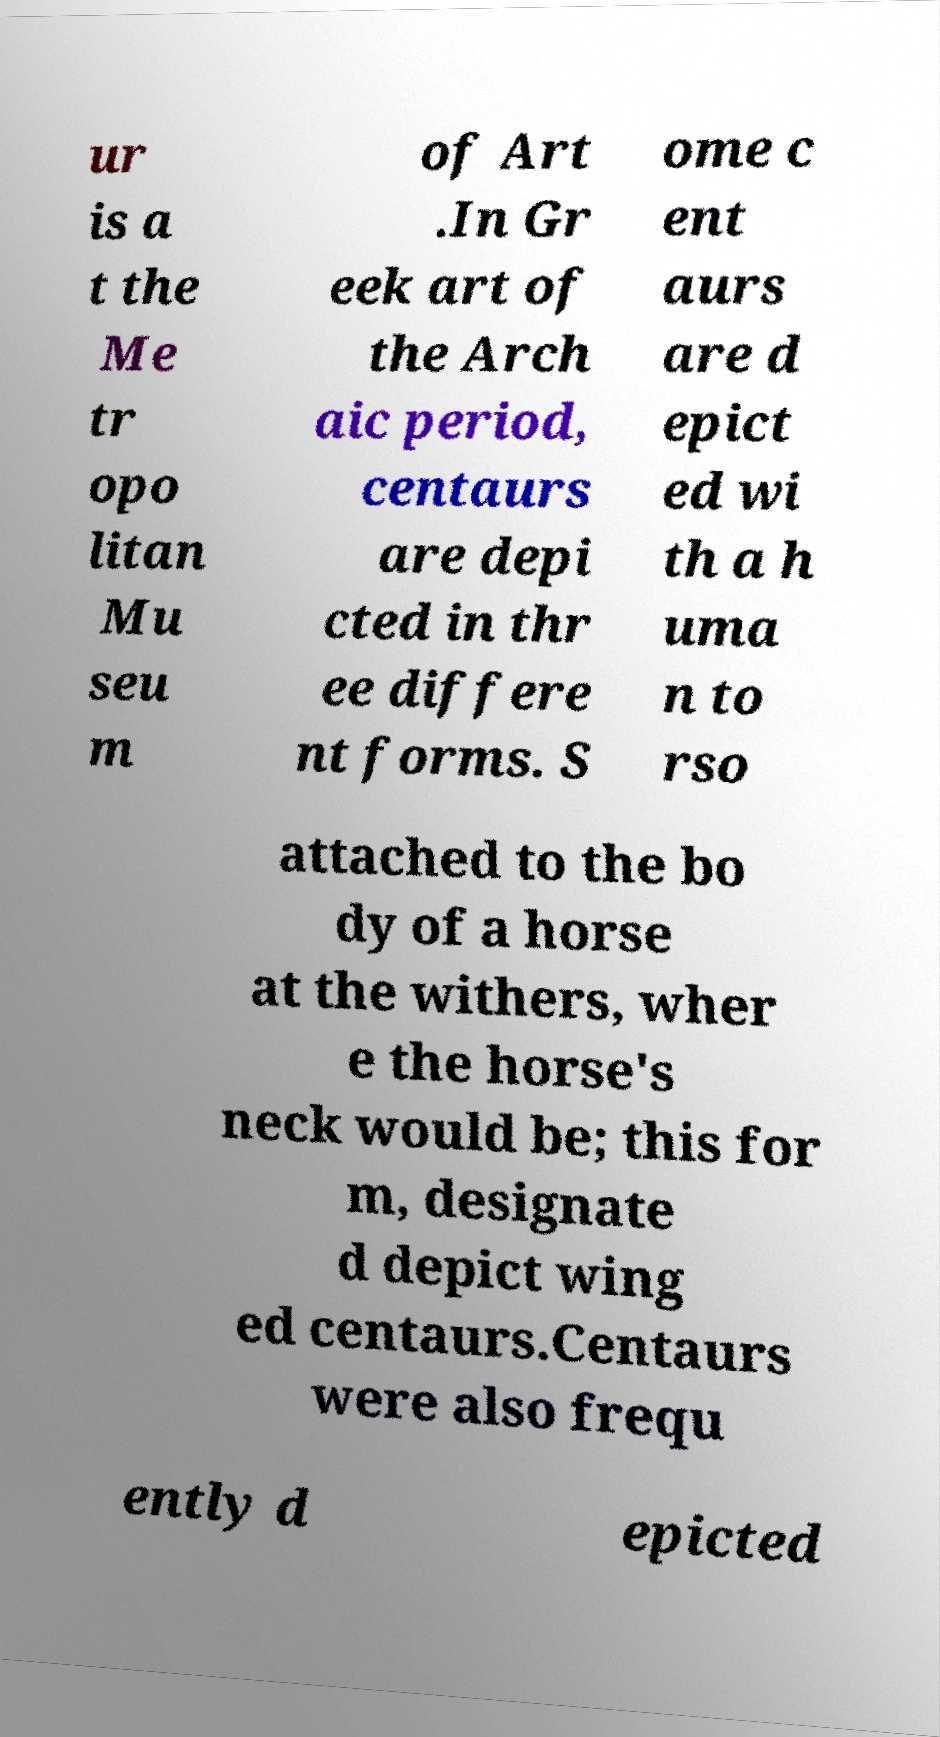What messages or text are displayed in this image? I need them in a readable, typed format. ur is a t the Me tr opo litan Mu seu m of Art .In Gr eek art of the Arch aic period, centaurs are depi cted in thr ee differe nt forms. S ome c ent aurs are d epict ed wi th a h uma n to rso attached to the bo dy of a horse at the withers, wher e the horse's neck would be; this for m, designate d depict wing ed centaurs.Centaurs were also frequ ently d epicted 